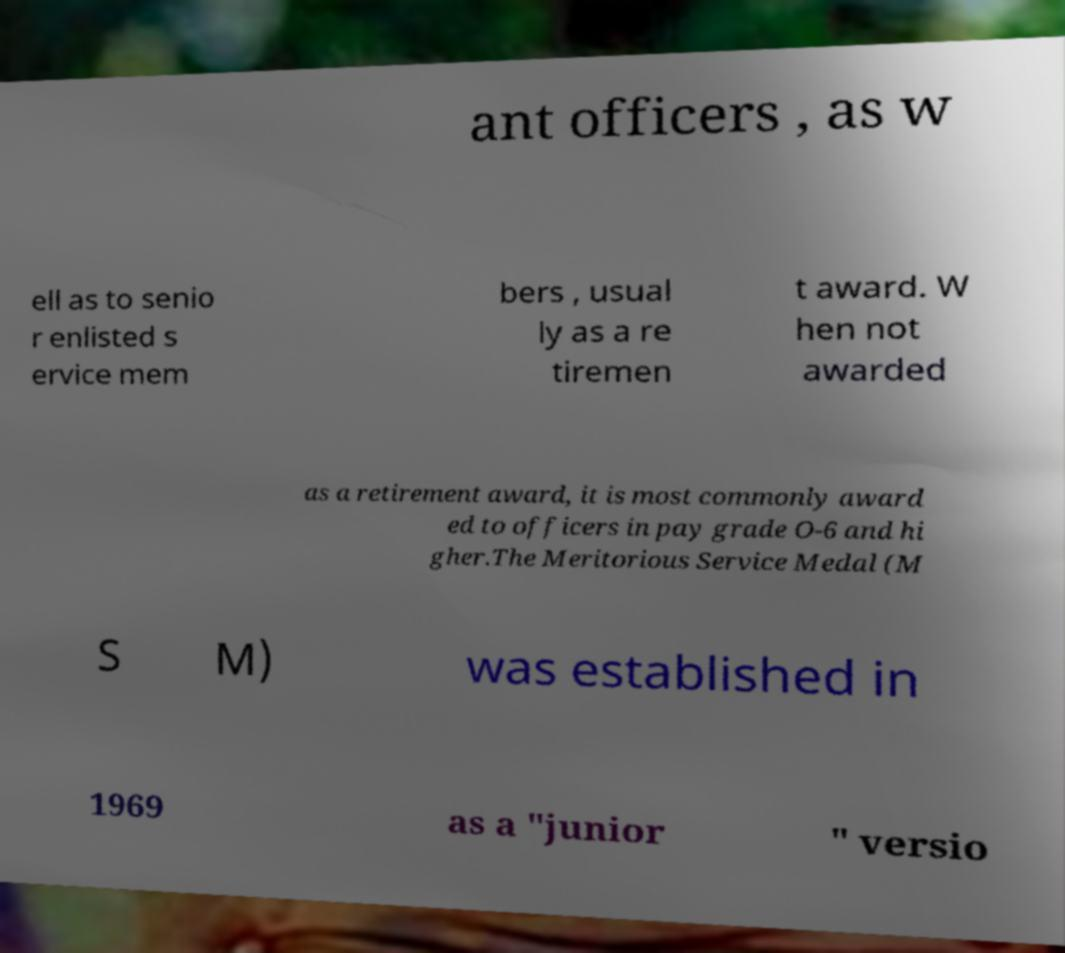Can you accurately transcribe the text from the provided image for me? ant officers , as w ell as to senio r enlisted s ervice mem bers , usual ly as a re tiremen t award. W hen not awarded as a retirement award, it is most commonly award ed to officers in pay grade O-6 and hi gher.The Meritorious Service Medal (M S M) was established in 1969 as a "junior " versio 